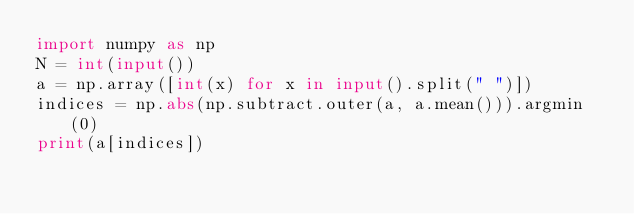<code> <loc_0><loc_0><loc_500><loc_500><_Python_>import numpy as np
N = int(input())
a = np.array([int(x) for x in input().split(" ")])
indices = np.abs(np.subtract.outer(a, a.mean())).argmin(0)
print(a[indices])</code> 